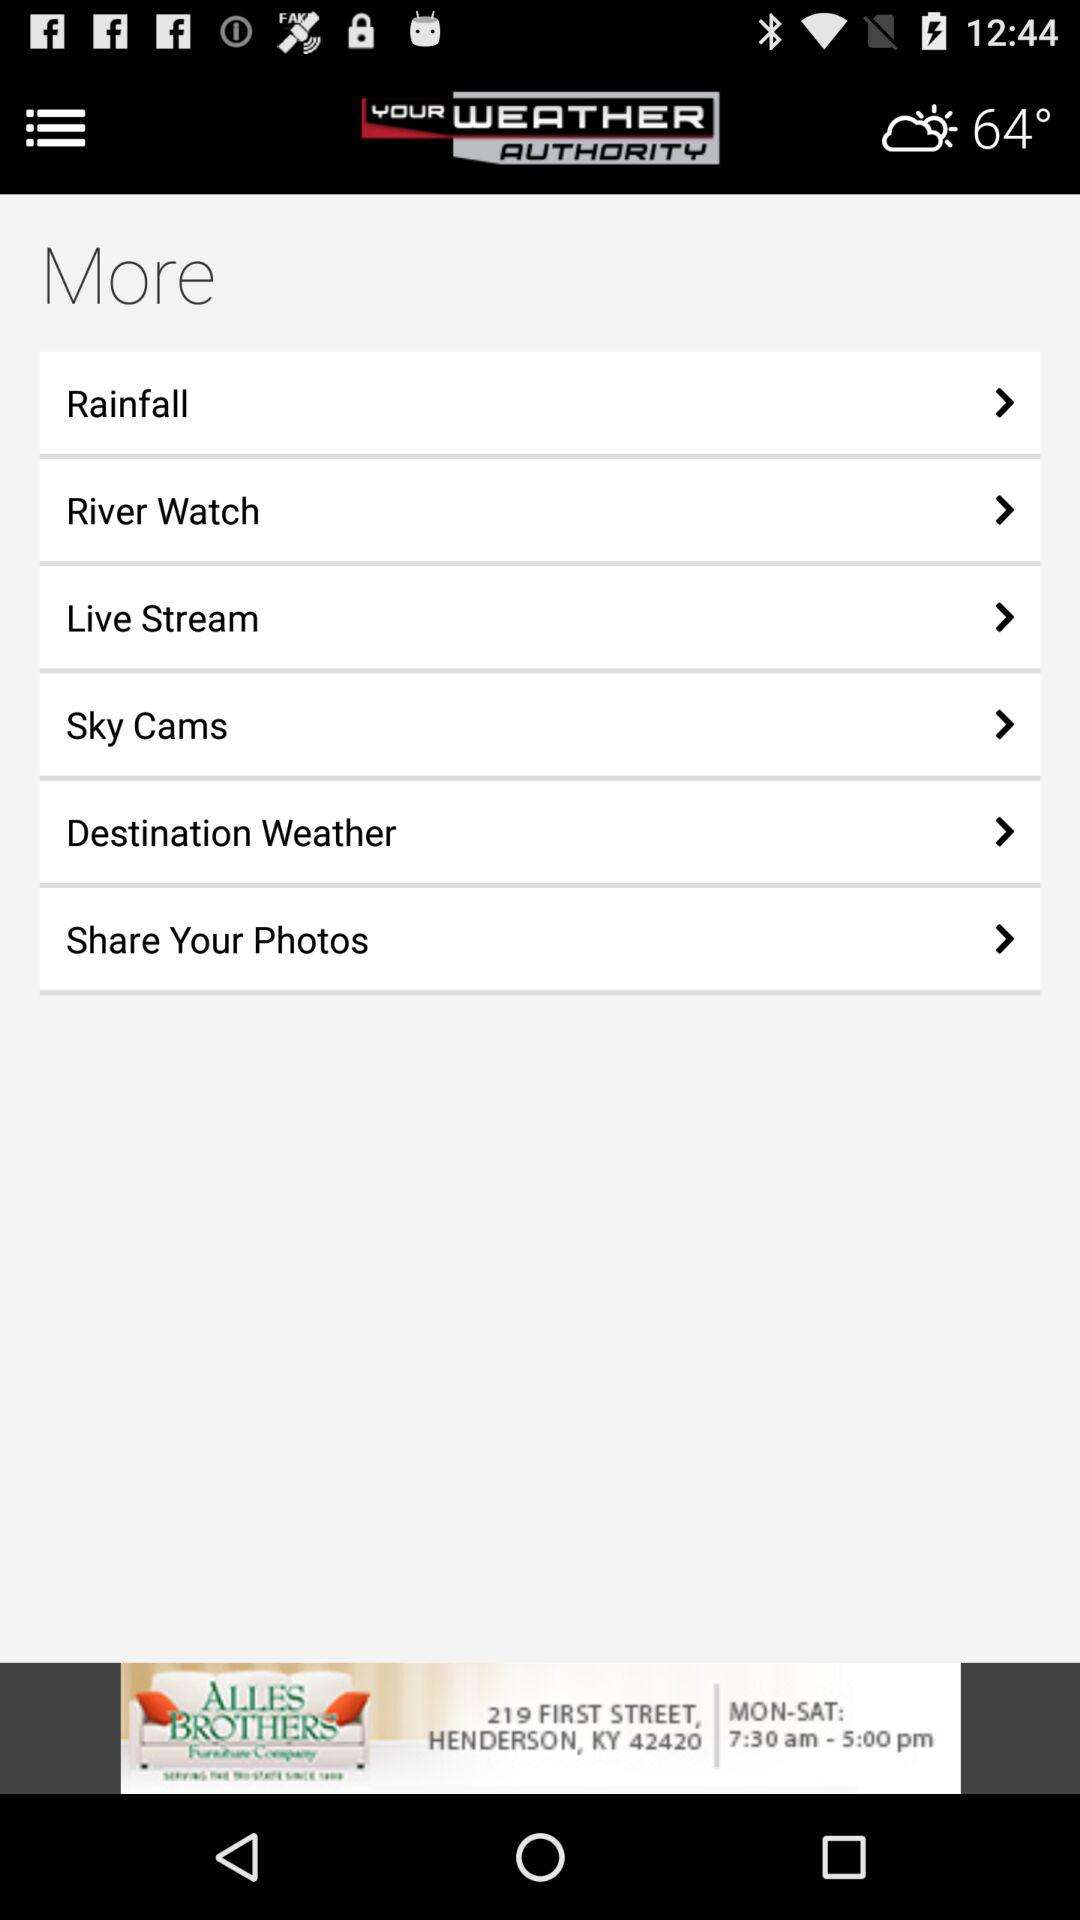What is the name of the application? The name of the application is "YOUR WEATHER AUTHORITY". 